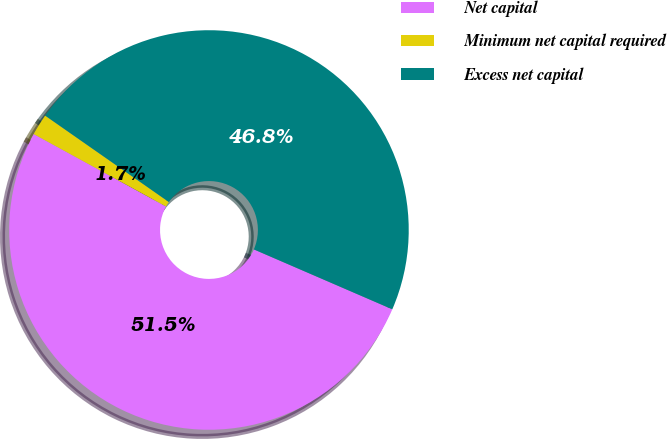<chart> <loc_0><loc_0><loc_500><loc_500><pie_chart><fcel>Net capital<fcel>Minimum net capital required<fcel>Excess net capital<nl><fcel>51.48%<fcel>1.73%<fcel>46.8%<nl></chart> 